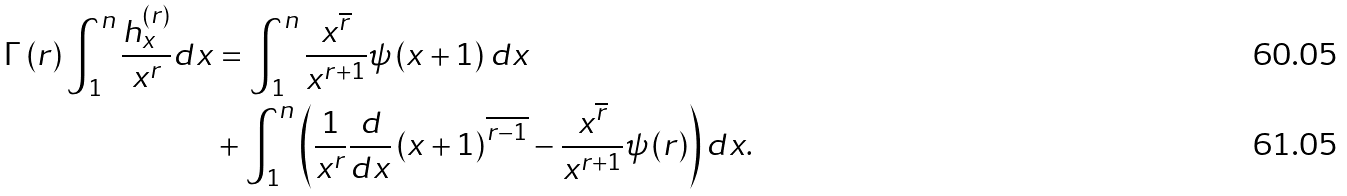Convert formula to latex. <formula><loc_0><loc_0><loc_500><loc_500>\Gamma \left ( r \right ) \int _ { 1 } ^ { n } \frac { h _ { x } ^ { \left ( r \right ) } } { x ^ { r } } d x & = \int _ { 1 } ^ { n } \frac { x ^ { \overline { r } } } { x ^ { r + 1 } } \psi \left ( x + 1 \right ) d x \\ & + \int _ { 1 } ^ { n } \left ( \frac { 1 } { x ^ { r } } \frac { d } { d x } \left ( x + 1 \right ) ^ { \overline { r - 1 } } - \frac { x ^ { \overline { r } } } { x ^ { r + 1 } } \psi \left ( r \right ) \right ) d x .</formula> 